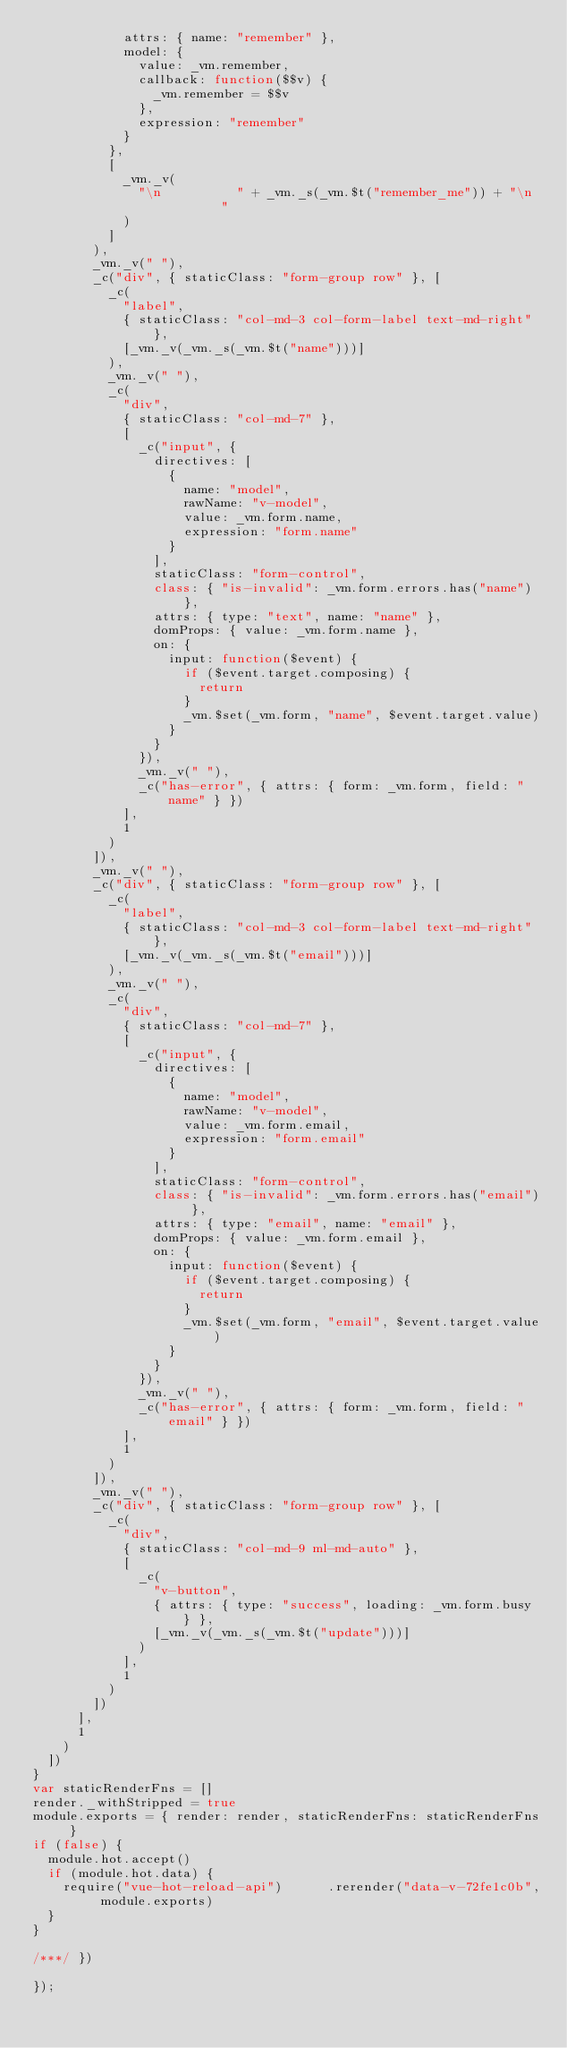Convert code to text. <code><loc_0><loc_0><loc_500><loc_500><_JavaScript_>            attrs: { name: "remember" },
            model: {
              value: _vm.remember,
              callback: function($$v) {
                _vm.remember = $$v
              },
              expression: "remember"
            }
          },
          [
            _vm._v(
              "\n          " + _vm._s(_vm.$t("remember_me")) + "\n        "
            )
          ]
        ),
        _vm._v(" "),
        _c("div", { staticClass: "form-group row" }, [
          _c(
            "label",
            { staticClass: "col-md-3 col-form-label text-md-right" },
            [_vm._v(_vm._s(_vm.$t("name")))]
          ),
          _vm._v(" "),
          _c(
            "div",
            { staticClass: "col-md-7" },
            [
              _c("input", {
                directives: [
                  {
                    name: "model",
                    rawName: "v-model",
                    value: _vm.form.name,
                    expression: "form.name"
                  }
                ],
                staticClass: "form-control",
                class: { "is-invalid": _vm.form.errors.has("name") },
                attrs: { type: "text", name: "name" },
                domProps: { value: _vm.form.name },
                on: {
                  input: function($event) {
                    if ($event.target.composing) {
                      return
                    }
                    _vm.$set(_vm.form, "name", $event.target.value)
                  }
                }
              }),
              _vm._v(" "),
              _c("has-error", { attrs: { form: _vm.form, field: "name" } })
            ],
            1
          )
        ]),
        _vm._v(" "),
        _c("div", { staticClass: "form-group row" }, [
          _c(
            "label",
            { staticClass: "col-md-3 col-form-label text-md-right" },
            [_vm._v(_vm._s(_vm.$t("email")))]
          ),
          _vm._v(" "),
          _c(
            "div",
            { staticClass: "col-md-7" },
            [
              _c("input", {
                directives: [
                  {
                    name: "model",
                    rawName: "v-model",
                    value: _vm.form.email,
                    expression: "form.email"
                  }
                ],
                staticClass: "form-control",
                class: { "is-invalid": _vm.form.errors.has("email") },
                attrs: { type: "email", name: "email" },
                domProps: { value: _vm.form.email },
                on: {
                  input: function($event) {
                    if ($event.target.composing) {
                      return
                    }
                    _vm.$set(_vm.form, "email", $event.target.value)
                  }
                }
              }),
              _vm._v(" "),
              _c("has-error", { attrs: { form: _vm.form, field: "email" } })
            ],
            1
          )
        ]),
        _vm._v(" "),
        _c("div", { staticClass: "form-group row" }, [
          _c(
            "div",
            { staticClass: "col-md-9 ml-md-auto" },
            [
              _c(
                "v-button",
                { attrs: { type: "success", loading: _vm.form.busy } },
                [_vm._v(_vm._s(_vm.$t("update")))]
              )
            ],
            1
          )
        ])
      ],
      1
    )
  ])
}
var staticRenderFns = []
render._withStripped = true
module.exports = { render: render, staticRenderFns: staticRenderFns }
if (false) {
  module.hot.accept()
  if (module.hot.data) {
    require("vue-hot-reload-api")      .rerender("data-v-72fe1c0b", module.exports)
  }
}

/***/ })

});</code> 